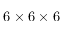Convert formula to latex. <formula><loc_0><loc_0><loc_500><loc_500>6 \times 6 \times 6</formula> 